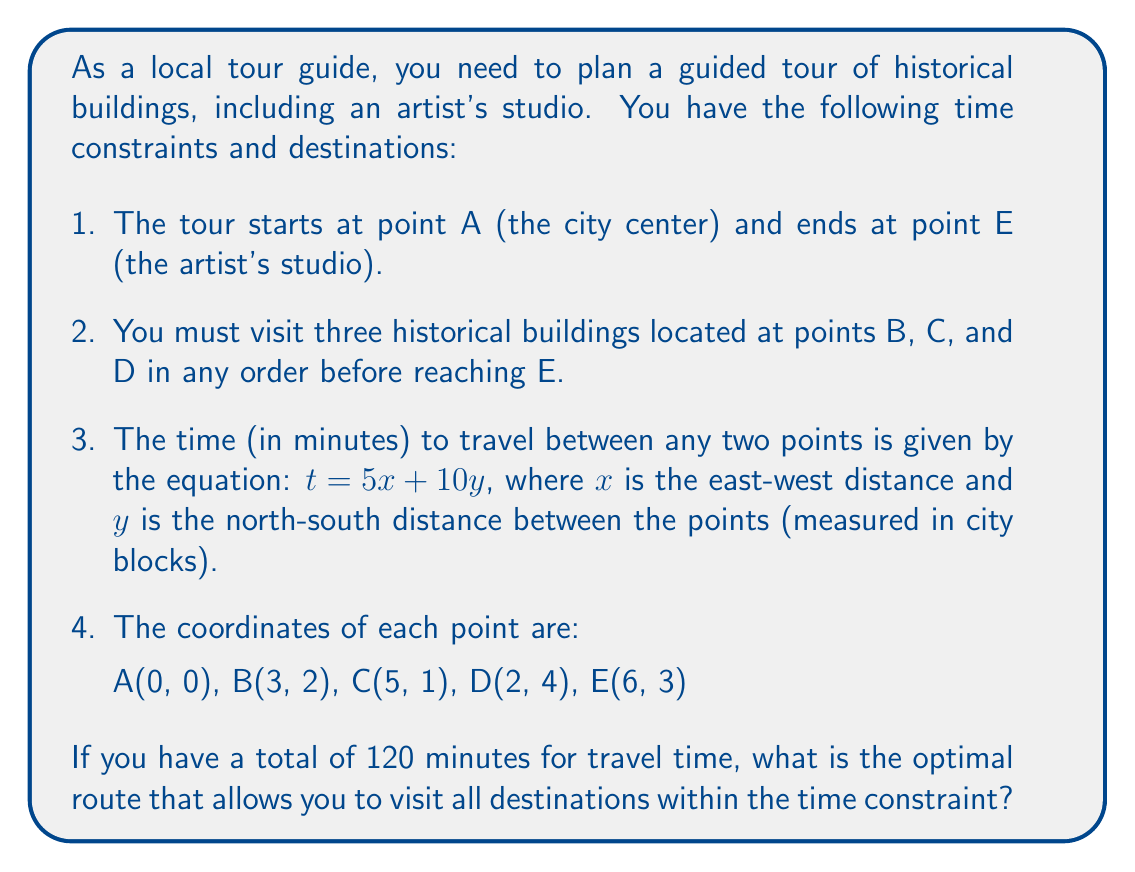Teach me how to tackle this problem. To solve this problem, we need to follow these steps:

1. Calculate the travel time between all pairs of points using the given equation.
2. Determine all possible routes from A to E, visiting B, C, and D in different orders.
3. Calculate the total travel time for each route.
4. Identify the route with the shortest total travel time.

Step 1: Calculate travel times

Let's use the equation $t = 5x + 10y$ to calculate the travel time between each pair of points. We'll use the absolute difference in coordinates to find $x$ and $y$.

For example, from A to B:
$x = |3 - 0| = 3$
$y = |2 - 0| = 2$
$t = 5(3) + 10(2) = 15 + 20 = 35$ minutes

Calculating for all pairs:

A to B: 35 min
A to C: 35 min
A to D: 50 min
B to C: 15 min
B to D: 25 min
B to E: 25 min
C to D: 35 min
C to E: 20 min
D to E: 35 min

Step 2: Determine possible routes

There are 6 possible routes:
1. A -> B -> C -> D -> E
2. A -> B -> D -> C -> E
3. A -> C -> B -> D -> E
4. A -> C -> D -> B -> E
5. A -> D -> B -> C -> E
6. A -> D -> C -> B -> E

Step 3: Calculate total travel time for each route

1. A -> B -> C -> D -> E = 35 + 15 + 35 + 35 = 120 min
2. A -> B -> D -> C -> E = 35 + 25 + 35 + 20 = 115 min
3. A -> C -> B -> D -> E = 35 + 15 + 25 + 35 = 110 min
4. A -> C -> D -> B -> E = 35 + 35 + 25 + 25 = 120 min
5. A -> D -> B -> C -> E = 50 + 25 + 15 + 20 = 110 min
6. A -> D -> C -> B -> E = 50 + 35 + 15 + 25 = 125 min

Step 4: Identify the optimal route

From our calculations, we can see that there are two routes with the shortest total travel time of 110 minutes:
- A -> C -> B -> D -> E
- A -> D -> B -> C -> E

Both of these routes satisfy the time constraint of 120 minutes.
Answer: The optimal routes are:
1. A -> C -> B -> D -> E
2. A -> D -> B -> C -> E

Both routes have a total travel time of 110 minutes, which is within the 120-minute constraint. 